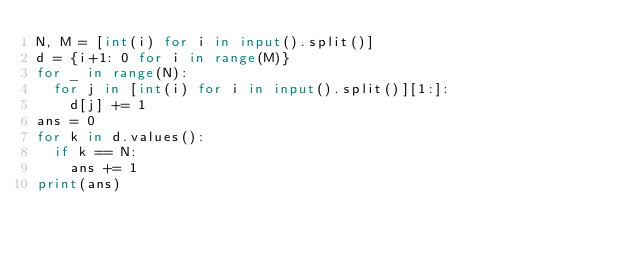<code> <loc_0><loc_0><loc_500><loc_500><_Python_>N, M = [int(i) for i in input().split()]
d = {i+1: 0 for i in range(M)}
for _ in range(N):
  for j in [int(i) for i in input().split()][1:]:
    d[j] += 1
ans = 0
for k in d.values():
  if k == N:
    ans += 1
print(ans)</code> 